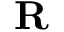<formula> <loc_0><loc_0><loc_500><loc_500>R</formula> 